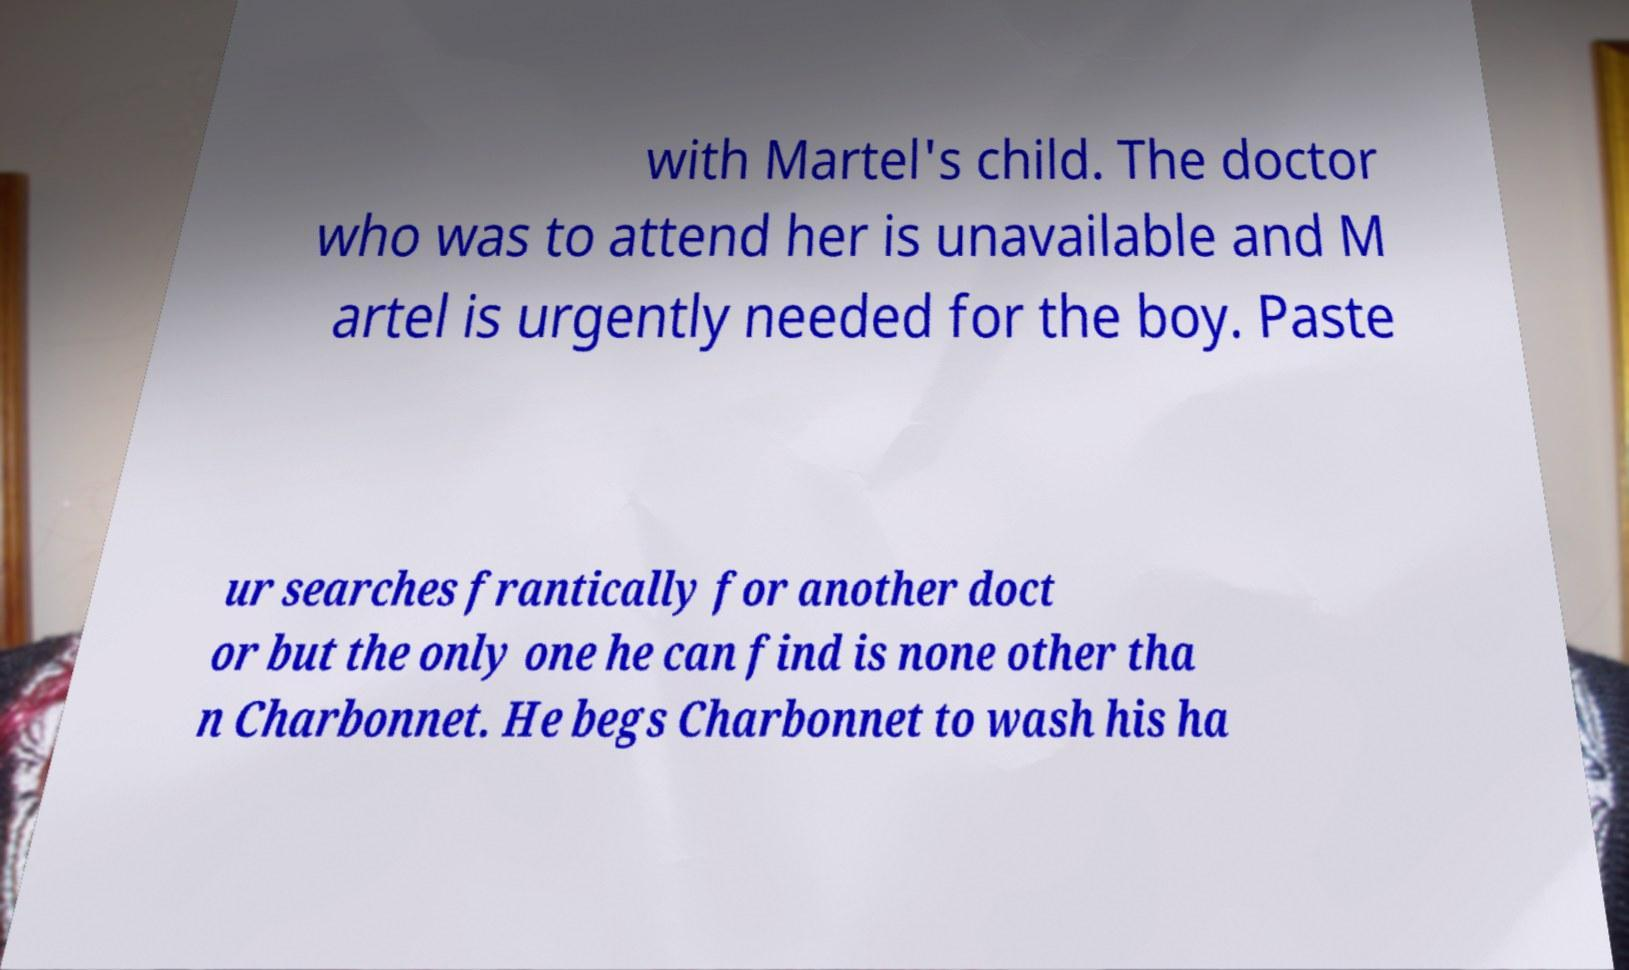For documentation purposes, I need the text within this image transcribed. Could you provide that? with Martel's child. The doctor who was to attend her is unavailable and M artel is urgently needed for the boy. Paste ur searches frantically for another doct or but the only one he can find is none other tha n Charbonnet. He begs Charbonnet to wash his ha 